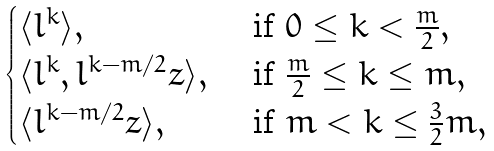Convert formula to latex. <formula><loc_0><loc_0><loc_500><loc_500>\begin{cases} \langle l ^ { k } \rangle , & \text { if } 0 \leq k < \frac { m } 2 , \\ \langle l ^ { k } , l ^ { k - m / 2 } z \rangle , & \text { if } \frac { m } 2 \leq k \leq m , \\ \langle l ^ { k - m / 2 } z \rangle , & \text { if } m < k \leq \frac { 3 } { 2 } m , \end{cases}</formula> 